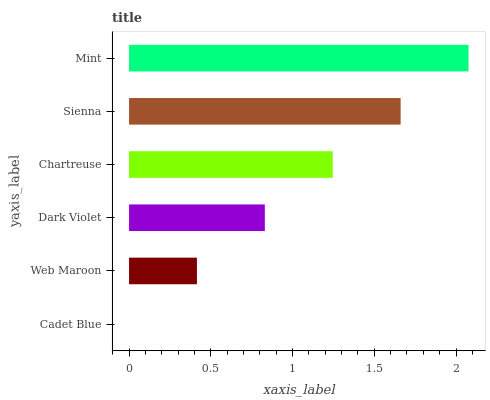Is Cadet Blue the minimum?
Answer yes or no. Yes. Is Mint the maximum?
Answer yes or no. Yes. Is Web Maroon the minimum?
Answer yes or no. No. Is Web Maroon the maximum?
Answer yes or no. No. Is Web Maroon greater than Cadet Blue?
Answer yes or no. Yes. Is Cadet Blue less than Web Maroon?
Answer yes or no. Yes. Is Cadet Blue greater than Web Maroon?
Answer yes or no. No. Is Web Maroon less than Cadet Blue?
Answer yes or no. No. Is Chartreuse the high median?
Answer yes or no. Yes. Is Dark Violet the low median?
Answer yes or no. Yes. Is Web Maroon the high median?
Answer yes or no. No. Is Cadet Blue the low median?
Answer yes or no. No. 